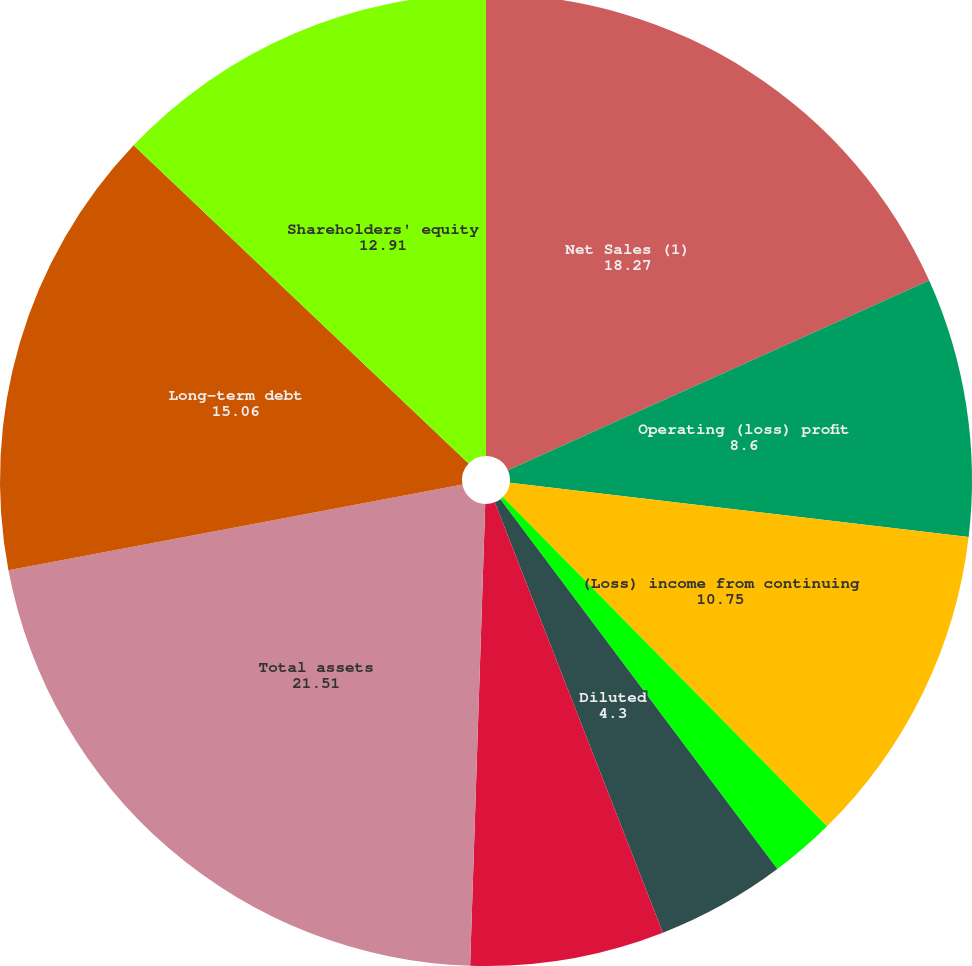Convert chart to OTSL. <chart><loc_0><loc_0><loc_500><loc_500><pie_chart><fcel>Net Sales (1)<fcel>Operating (loss) profit<fcel>(Loss) income from continuing<fcel>Basic<fcel>Diluted<fcel>Dividends declared<fcel>Dividends paid<fcel>Total assets<fcel>Long-term debt<fcel>Shareholders' equity<nl><fcel>18.27%<fcel>8.6%<fcel>10.75%<fcel>2.15%<fcel>4.3%<fcel>0.0%<fcel>6.45%<fcel>21.51%<fcel>15.06%<fcel>12.91%<nl></chart> 